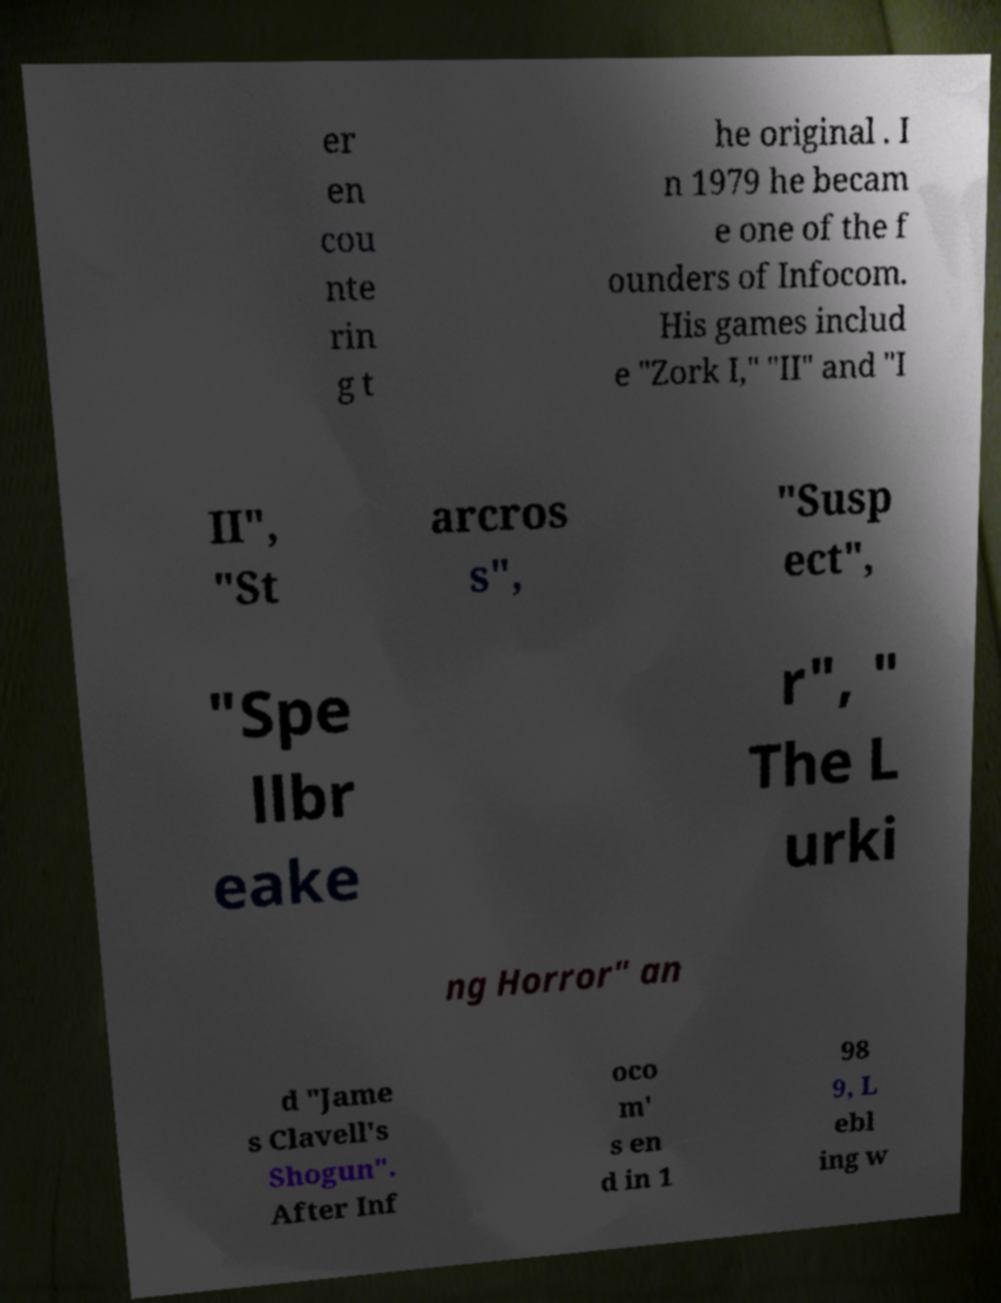Can you read and provide the text displayed in the image?This photo seems to have some interesting text. Can you extract and type it out for me? er en cou nte rin g t he original . I n 1979 he becam e one of the f ounders of Infocom. His games includ e "Zork I," "II" and "I II", "St arcros s", "Susp ect", "Spe llbr eake r", " The L urki ng Horror" an d "Jame s Clavell's Shogun". After Inf oco m' s en d in 1 98 9, L ebl ing w 